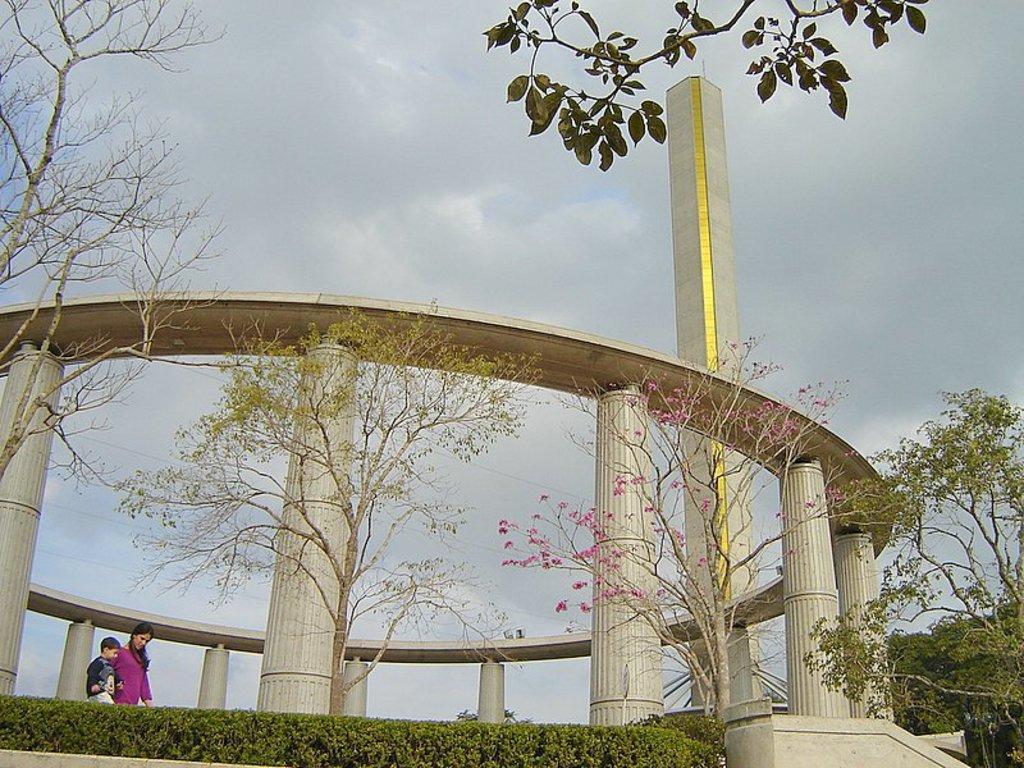How would you summarize this image in a sentence or two? In this image two people were walking on the road. At the back side there are trees, building and sky. 